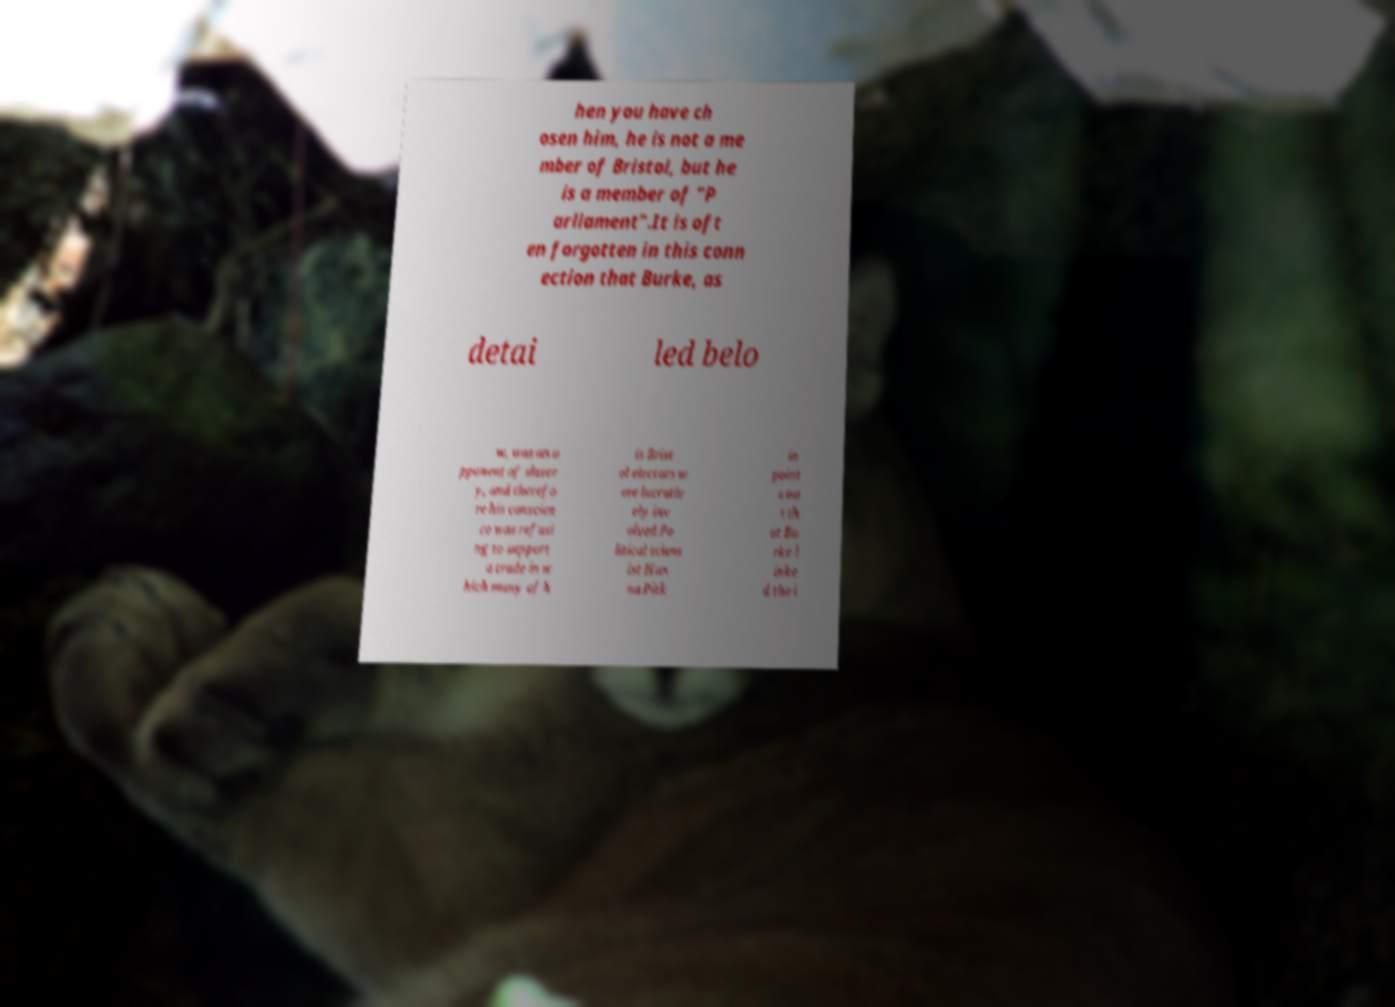What messages or text are displayed in this image? I need them in a readable, typed format. hen you have ch osen him, he is not a me mber of Bristol, but he is a member of "P arliament".It is oft en forgotten in this conn ection that Burke, as detai led belo w, was an o pponent of slaver y, and therefo re his conscien ce was refusi ng to support a trade in w hich many of h is Brist ol electors w ere lucrativ ely inv olved.Po litical scient ist Han na Pitk in point s ou t th at Bu rke l inke d the i 